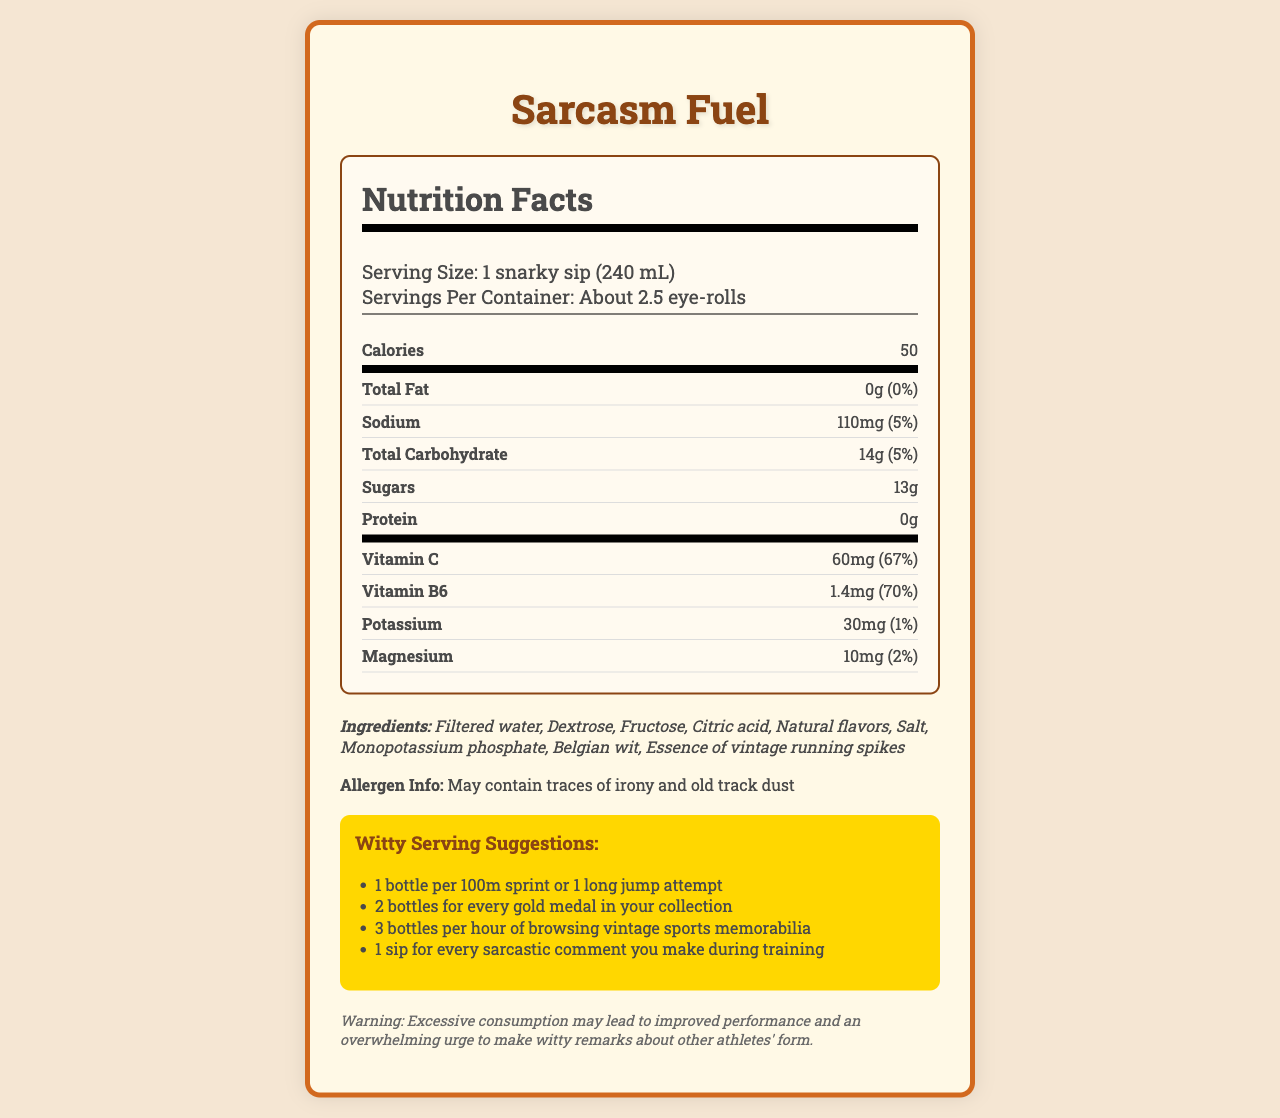what is the serving size for Sarcasm Fuel? The document explicitly states the serving size as "1 snarky sip (240 mL)".
Answer: 1 snarky sip (240 mL) how many calories are in one serving? According to the document, each serving contains 50 calories.
Answer: 50 what is the total carbohydrate content in one serving? The document lists the total carbohydrate content per serving as 14g.
Answer: 14g how much vitamin C is in one serving? The document specifies that there is 60mg of vitamin C per serving.
Answer: 60mg what are the serving suggestions for Sarcasm Fuel? The document includes witty serving suggestions for various activities.
Answer: 1 bottle per 100m sprint or 1 long jump attempt, 2 bottles for every gold medal in your collection, 3 bottles per hour of browsing vintage sports memorabilia, 1 sip for every sarcastic comment you make during training which ingredient is not typically found in sports drinks? A. Citric acid B. Monopotassium phosphate C. Belgian wit D. Fructose Belgian wit is the unusual ingredient compared to the others listed.
Answer: C what is the sodium content in one serving? A. 110mg B. 68mg C. 150mg D. 30mg The sodium content per serving is shown as 110mg.
Answer: A can this drink improve performance and make you more witty? (Yes/No) The disclaimer humorously suggests that excessive consumption may improve performance and increase the urge to make witty remarks.
Answer: Yes summarize the main idea of the document. This document highlights the nutritional content and adds a humorous touch with witty suggestions and a playful disclaimer.
Answer: The document provides the nutritional facts of "Sarcasm Fuel," a sports drink with a sarcastic twist. It details serving size, calorie content, nutrient breakdown, ingredients, allergen information, witty serving suggestions, and a humorous disclaimer about the drink's effects. what is the source of protein in this drink? According to the document, the protein content is 0g.
Answer: There is no protein in this drink. how many servings are in one container of Sarcasm Fuel? The document humorously states that there are about 2.5 servings per container, referred to as "eye-rolls."
Answer: About 2.5 eye-rolls what is the allergen information provided? The allergen information humorously states that the drink may contain traces of irony and old track dust.
Answer: May contain traces of irony and old track dust which vitamin has a higher percent daily value in one serving, Vitamin C or Vitamin B6? Vitamin C has a percent daily value of 67%, whereas Vitamin B6 has a percent daily value of 70%.
Answer: Vitamin B6 how much potassium is in a serving? The document specifies that each serving contains 30mg of potassium.
Answer: 30mg what is the main flavor profile of Sarcasm Fuel? The document does not provide specific flavor details beyond listing "Natural flavors," so the main flavor profile cannot be determined.
Answer: Cannot be determined what humorous side effect does the disclaimer warn about? The disclaimer humorously warns that excessive consumption may lead to an overwhelming urge to make witty remarks about other athletes' form.
Answer: An overwhelming urge to make witty remarks about other athletes' form 